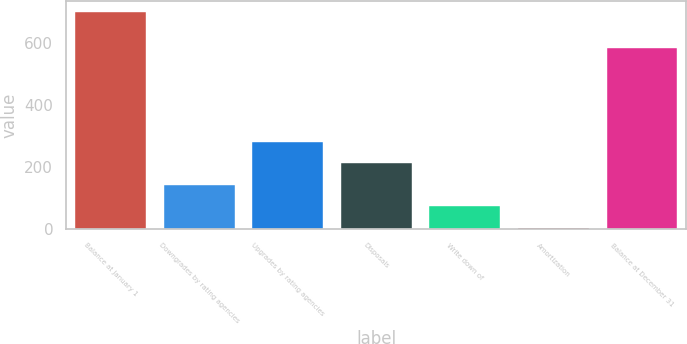<chart> <loc_0><loc_0><loc_500><loc_500><bar_chart><fcel>Balance at January 1<fcel>Downgrades by rating agencies<fcel>Upgrades by rating agencies<fcel>Disposals<fcel>Write down of<fcel>Amortization<fcel>Balance at December 31<nl><fcel>701<fcel>142.6<fcel>282.2<fcel>212.4<fcel>72.8<fcel>3<fcel>585<nl></chart> 